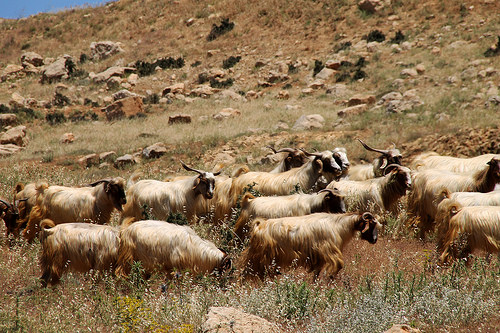<image>
Can you confirm if the head is on the body? No. The head is not positioned on the body. They may be near each other, but the head is not supported by or resting on top of the body. Is the stone in the grass? Yes. The stone is contained within or inside the grass, showing a containment relationship. 